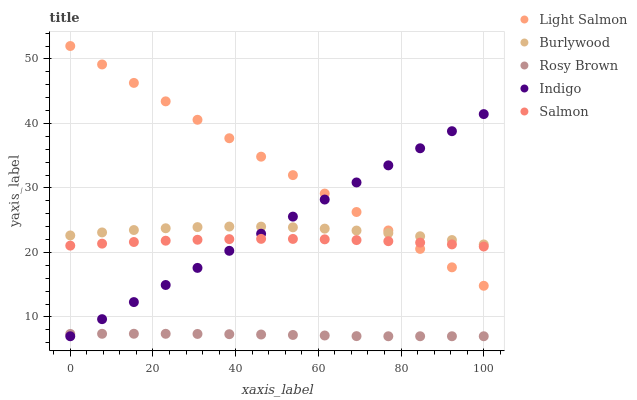Does Rosy Brown have the minimum area under the curve?
Answer yes or no. Yes. Does Light Salmon have the maximum area under the curve?
Answer yes or no. Yes. Does Salmon have the minimum area under the curve?
Answer yes or no. No. Does Salmon have the maximum area under the curve?
Answer yes or no. No. Is Light Salmon the smoothest?
Answer yes or no. Yes. Is Burlywood the roughest?
Answer yes or no. Yes. Is Salmon the smoothest?
Answer yes or no. No. Is Salmon the roughest?
Answer yes or no. No. Does Rosy Brown have the lowest value?
Answer yes or no. Yes. Does Salmon have the lowest value?
Answer yes or no. No. Does Light Salmon have the highest value?
Answer yes or no. Yes. Does Salmon have the highest value?
Answer yes or no. No. Is Rosy Brown less than Salmon?
Answer yes or no. Yes. Is Light Salmon greater than Rosy Brown?
Answer yes or no. Yes. Does Burlywood intersect Light Salmon?
Answer yes or no. Yes. Is Burlywood less than Light Salmon?
Answer yes or no. No. Is Burlywood greater than Light Salmon?
Answer yes or no. No. Does Rosy Brown intersect Salmon?
Answer yes or no. No. 